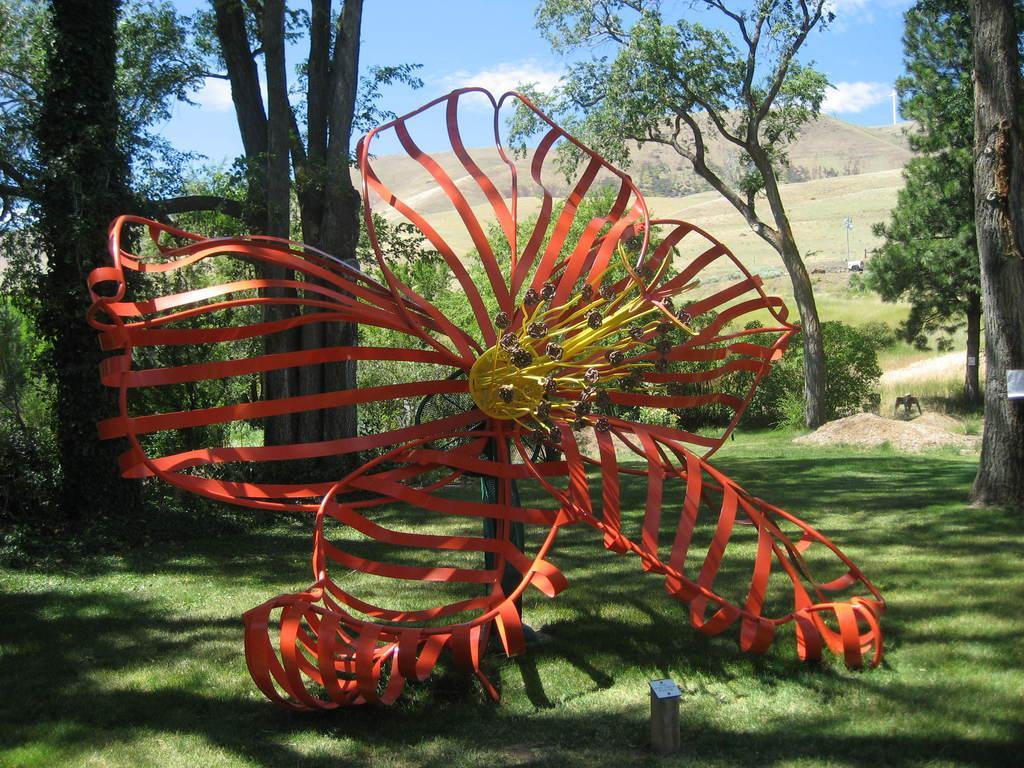Please provide a concise description of this image. In this image we can see a object which is orange and yellow in colour. Behind this object there are some trees,mountains and at the top we can see the sky. 